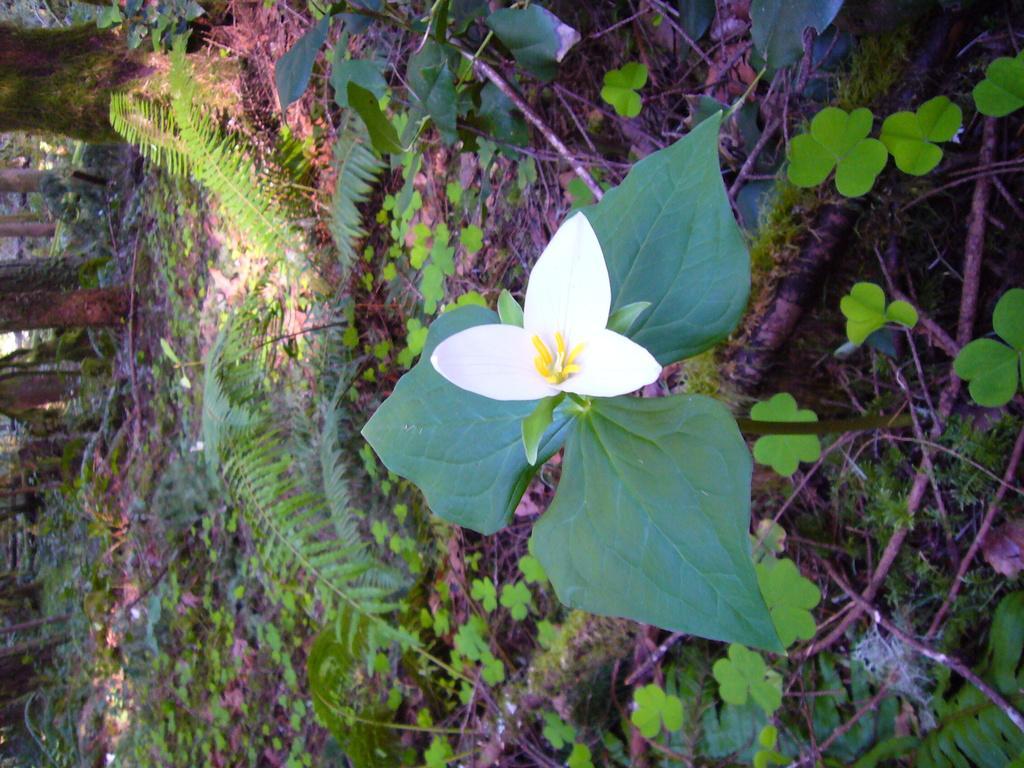Could you give a brief overview of what you see in this image? In this image I can see a white color flower and dew green color leaves. Back I can see few trees. 